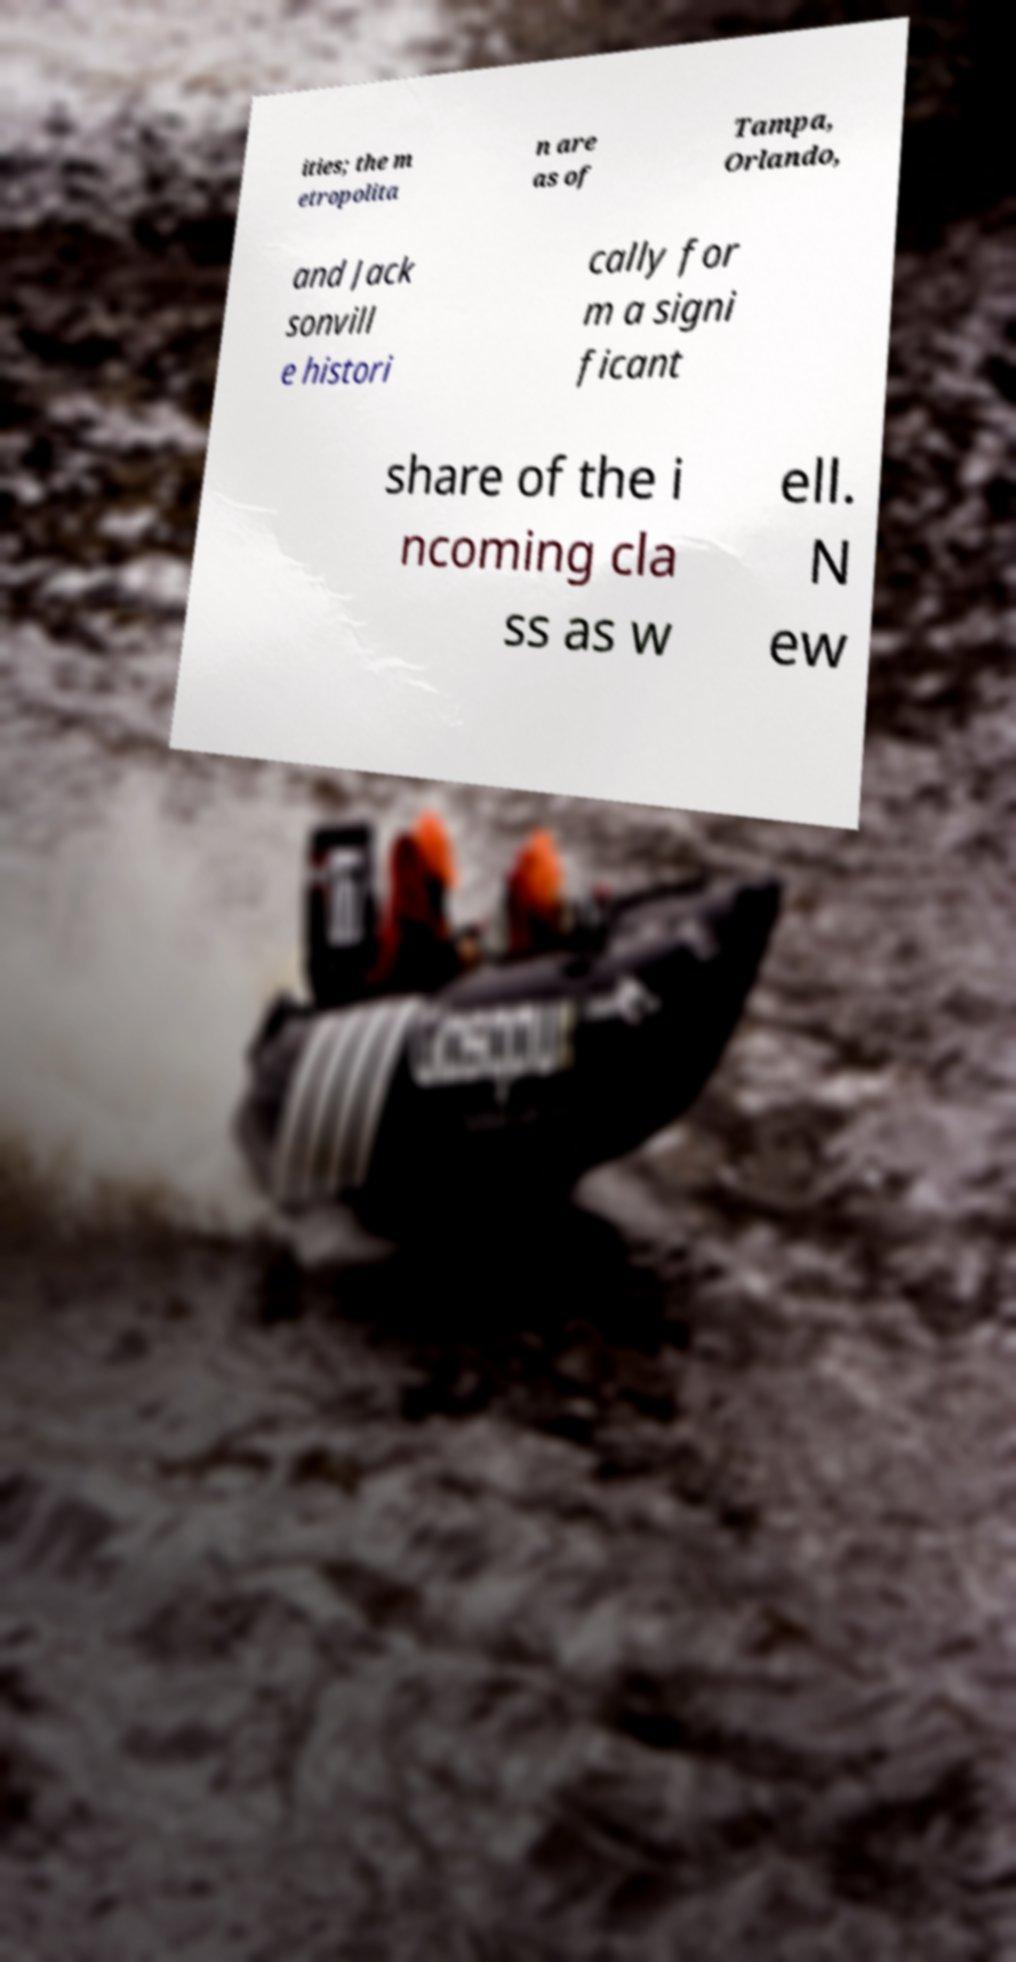What messages or text are displayed in this image? I need them in a readable, typed format. ities; the m etropolita n are as of Tampa, Orlando, and Jack sonvill e histori cally for m a signi ficant share of the i ncoming cla ss as w ell. N ew 